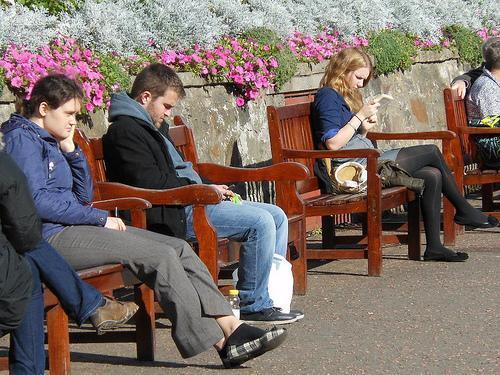How many people sitting on the benches in this image are reading books?
Give a very brief answer. 0. 